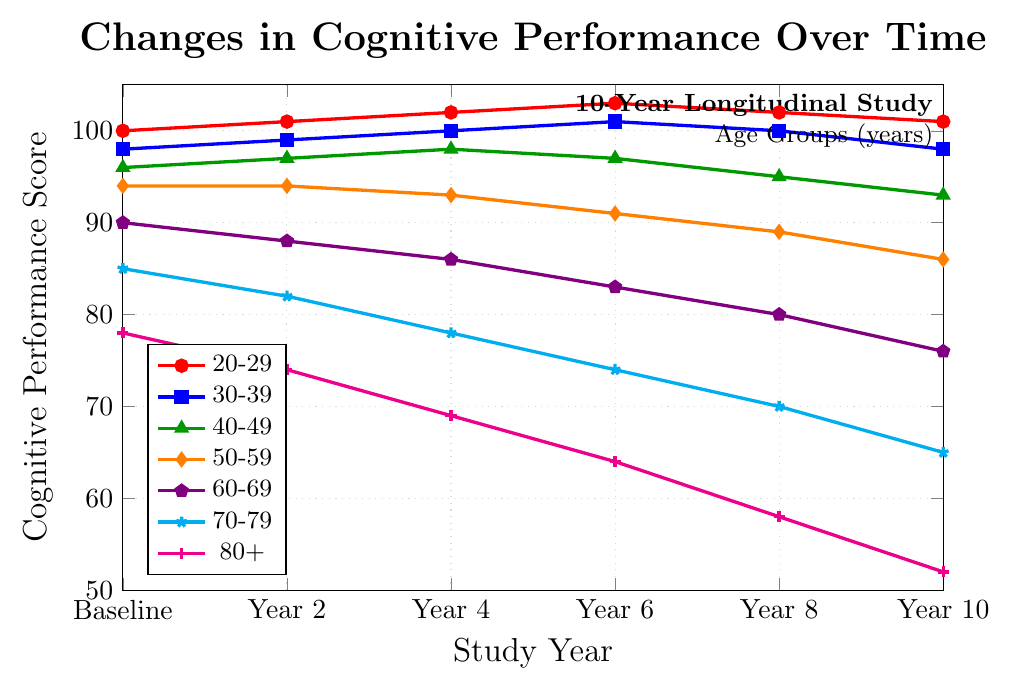what is the overall trend for the 20-29 age group? The line for the 20-29 age group shows a slight upward trend from the baseline score of 100 to a peak of 103 at Year 6, then it decreases slightly to 101 by Year 10. This indicates a slight improvement in cognitive performance over time with a small decline towards the end of the study period.
Answer: slight improvement with a small decline at the end How does the cognitive performance of the 80+ age group change over time? The cognitive performance for the 80+ age group shows a consistent decline, starting at a baseline score of 78 and decreasing steadily over the years to reach 52 by Year 10. This indicates a significant drop in cognitive performance over time.
Answer: consistent decline to 52 Which age group shows the least variation in cognitive performance? Observing the lines, the 50-59 age group shows the least variation, with scores ranging from 94 to 86. The differences between its highest and lowest scores are smaller compared to other groups.
Answer: 50-59 age group Identify the age group with the sharpest decline in cognitive performance from baseline to Year 10. By comparing the starting and ending points of each line, the 80+ age group shows the sharpest decline, dropping from 78 at baseline to 52 at Year 10, a total decrease of 26 points.
Answer: 80+ age group What is the average cognitive performance score for the 60-69 age group over the 10 years? To find the average score for the 60-69 age group: (90 + 88 + 86 + 83 + 80 + 76)/6 = 503/6 = approximately 83.83.
Answer: approximately 83.83 Compare the cognitive performance trends of the 30-39 and 40-49 age groups. The 30-39 group shows a slight improvement from 98 to 101 by Year 6, then a slight decrease to 98 by Year 10. The 40-49 group improves initially from 96 to 98 by Year 4, then declines to 93 by Year 10. Both groups show initial improvement followed by a decline, but the 40-49 group ends significantly lower.
Answer: both show initial improvement, then decline; 40-49 ends lower How much does the cognitive performance for the 70-79 age group decrease every two years on average? To find the average decrease per two years: (85-82) + (82-78) + (78-74) + (74-70) + (70-65) = 3+4+4+4+5 = 20 over 10 years, average decrease every two years is 20/5 = 4.
Answer: 4 points Which age group has the highest cognitive performance score at Year 10? Looking at the data points at Year 10 across all age groups, the 20-29 age group has the highest score with 101.
Answer: 20-29 age group How many age groups demonstrate an overall improvement in cognitive performance during the study? By examining each line's start and end points, only the 20-29 and 30-39 age groups show a higher end score compared to the start score, indicating overall improvement.
Answer: 2 age groups What is the largest drop in cognitive performance between any two consecutive years for the 60-69 age group? Comparing consecutive data points for the 60-69 age group: (90-88) = 2, (88-86) = 2, (86-83) = 3, (83-80) = 3, (80-76) = 4. The largest drop is from Year 8 to Year 10, with a 4 point decrease.
Answer: 4 points between Year 8 and Year 10 